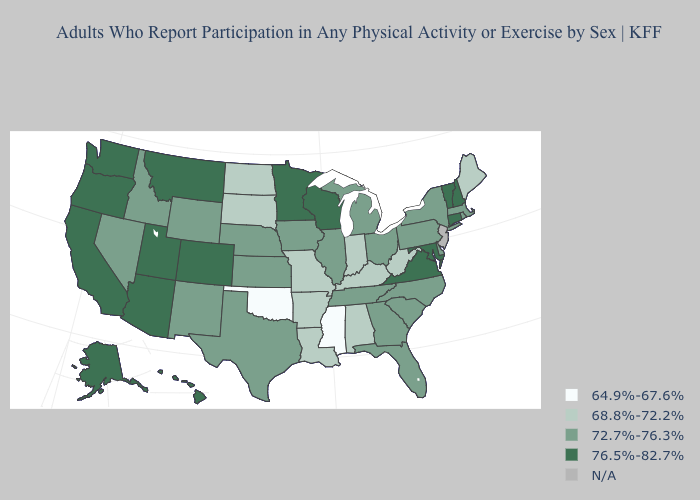Does the map have missing data?
Write a very short answer. Yes. Name the states that have a value in the range 64.9%-67.6%?
Be succinct. Mississippi, Oklahoma. Name the states that have a value in the range 72.7%-76.3%?
Give a very brief answer. Delaware, Florida, Georgia, Idaho, Illinois, Iowa, Kansas, Massachusetts, Michigan, Nebraska, Nevada, New Mexico, New York, North Carolina, Ohio, Pennsylvania, Rhode Island, South Carolina, Tennessee, Texas, Wyoming. What is the value of Michigan?
Short answer required. 72.7%-76.3%. Which states have the highest value in the USA?
Be succinct. Alaska, Arizona, California, Colorado, Connecticut, Hawaii, Maryland, Minnesota, Montana, New Hampshire, Oregon, Utah, Vermont, Virginia, Washington, Wisconsin. What is the value of Nevada?
Give a very brief answer. 72.7%-76.3%. What is the value of Kansas?
Give a very brief answer. 72.7%-76.3%. What is the value of New Hampshire?
Answer briefly. 76.5%-82.7%. Does Oregon have the lowest value in the USA?
Short answer required. No. Name the states that have a value in the range 76.5%-82.7%?
Write a very short answer. Alaska, Arizona, California, Colorado, Connecticut, Hawaii, Maryland, Minnesota, Montana, New Hampshire, Oregon, Utah, Vermont, Virginia, Washington, Wisconsin. Among the states that border Nevada , does Oregon have the lowest value?
Answer briefly. No. Name the states that have a value in the range 68.8%-72.2%?
Keep it brief. Alabama, Arkansas, Indiana, Kentucky, Louisiana, Maine, Missouri, North Dakota, South Dakota, West Virginia. What is the highest value in the South ?
Keep it brief. 76.5%-82.7%. 